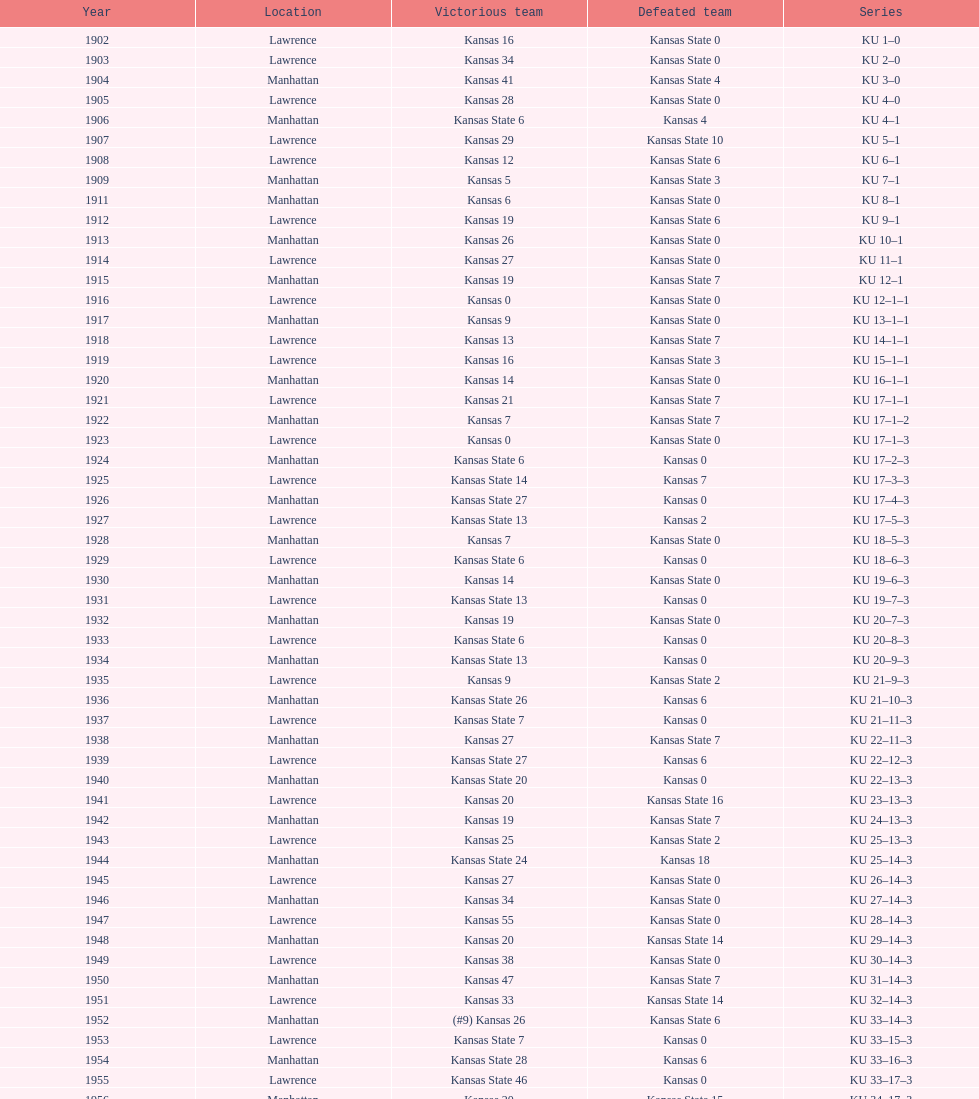Before 1950 what was the most points kansas scored? 55. 